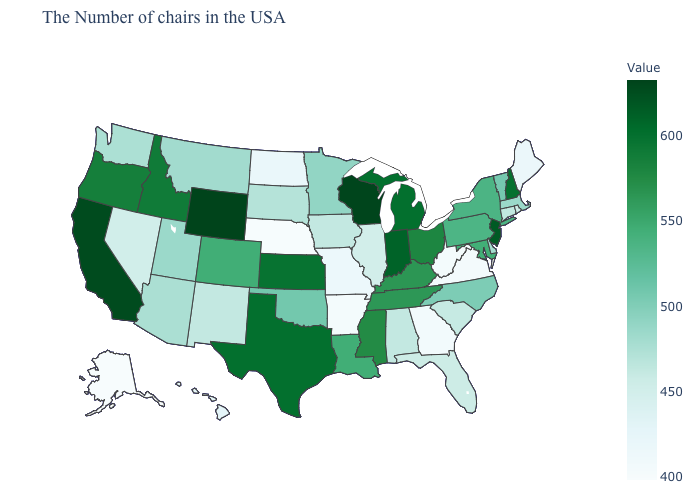Which states have the lowest value in the USA?
Quick response, please. Alaska. Which states have the lowest value in the Northeast?
Be succinct. Maine. Which states hav the highest value in the Northeast?
Be succinct. New Jersey. 